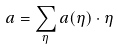<formula> <loc_0><loc_0><loc_500><loc_500>a = \sum _ { \eta } a ( \eta ) \cdot \eta</formula> 